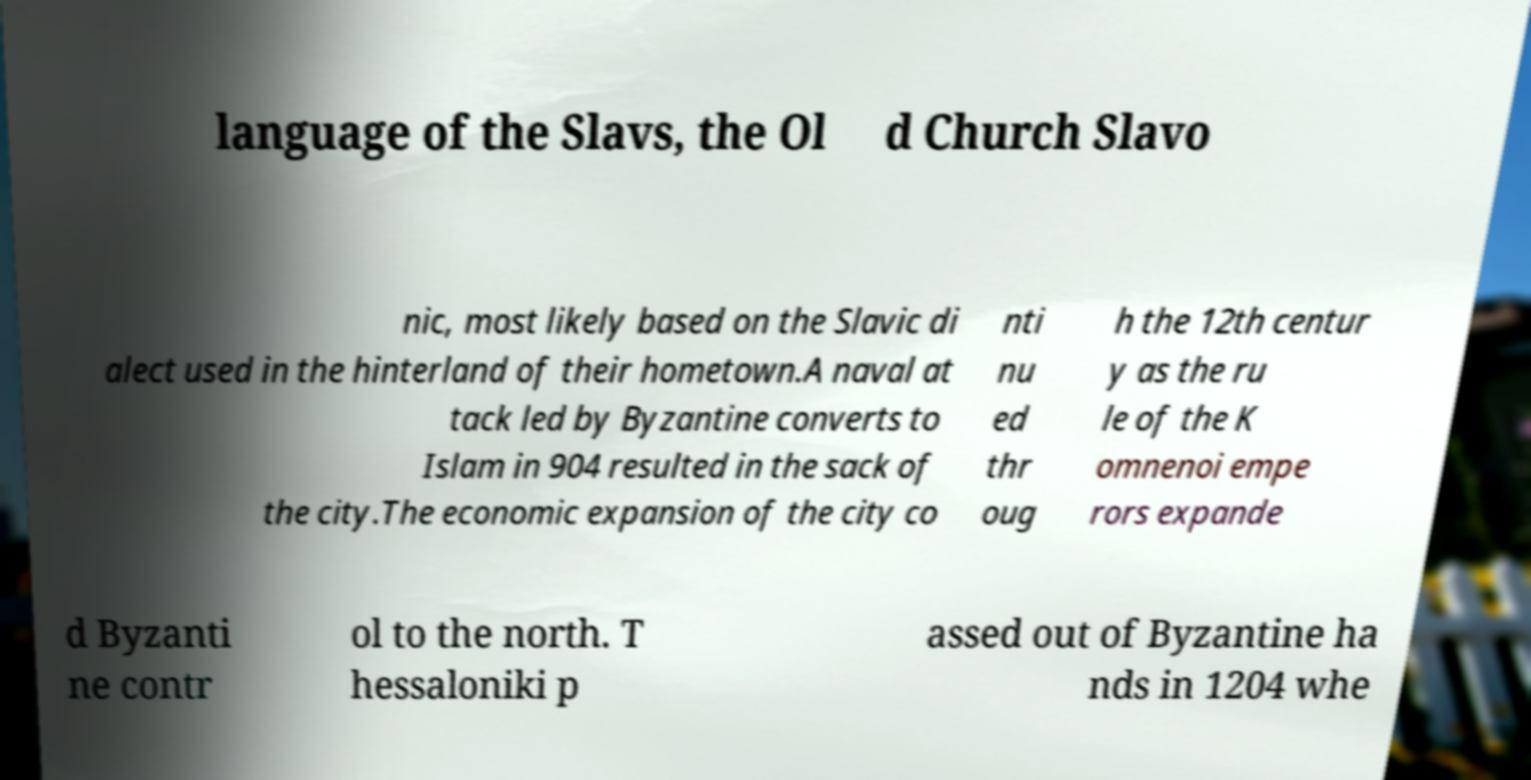There's text embedded in this image that I need extracted. Can you transcribe it verbatim? language of the Slavs, the Ol d Church Slavo nic, most likely based on the Slavic di alect used in the hinterland of their hometown.A naval at tack led by Byzantine converts to Islam in 904 resulted in the sack of the city.The economic expansion of the city co nti nu ed thr oug h the 12th centur y as the ru le of the K omnenoi empe rors expande d Byzanti ne contr ol to the north. T hessaloniki p assed out of Byzantine ha nds in 1204 whe 